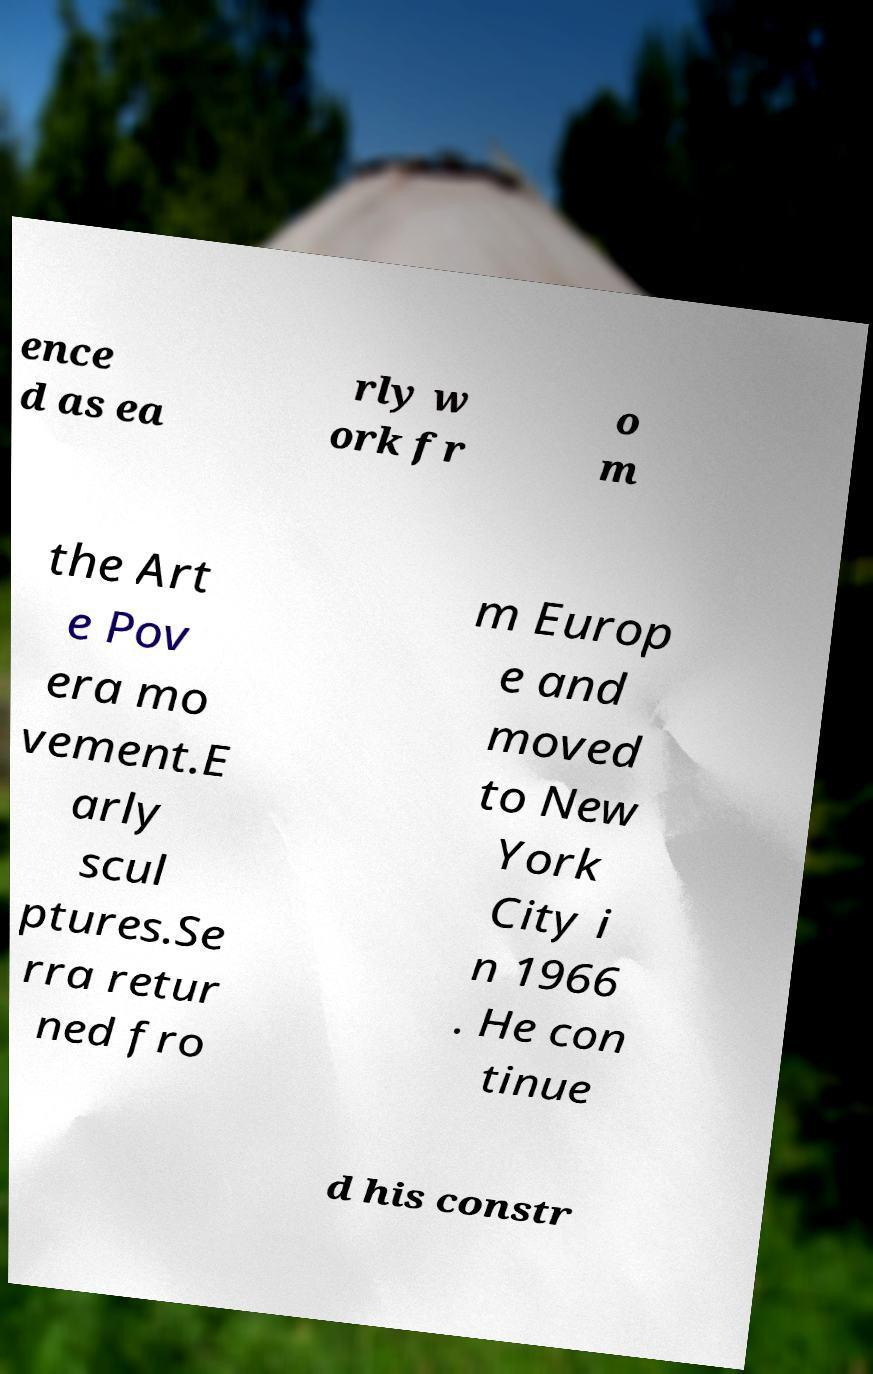Please read and relay the text visible in this image. What does it say? ence d as ea rly w ork fr o m the Art e Pov era mo vement.E arly scul ptures.Se rra retur ned fro m Europ e and moved to New York City i n 1966 . He con tinue d his constr 